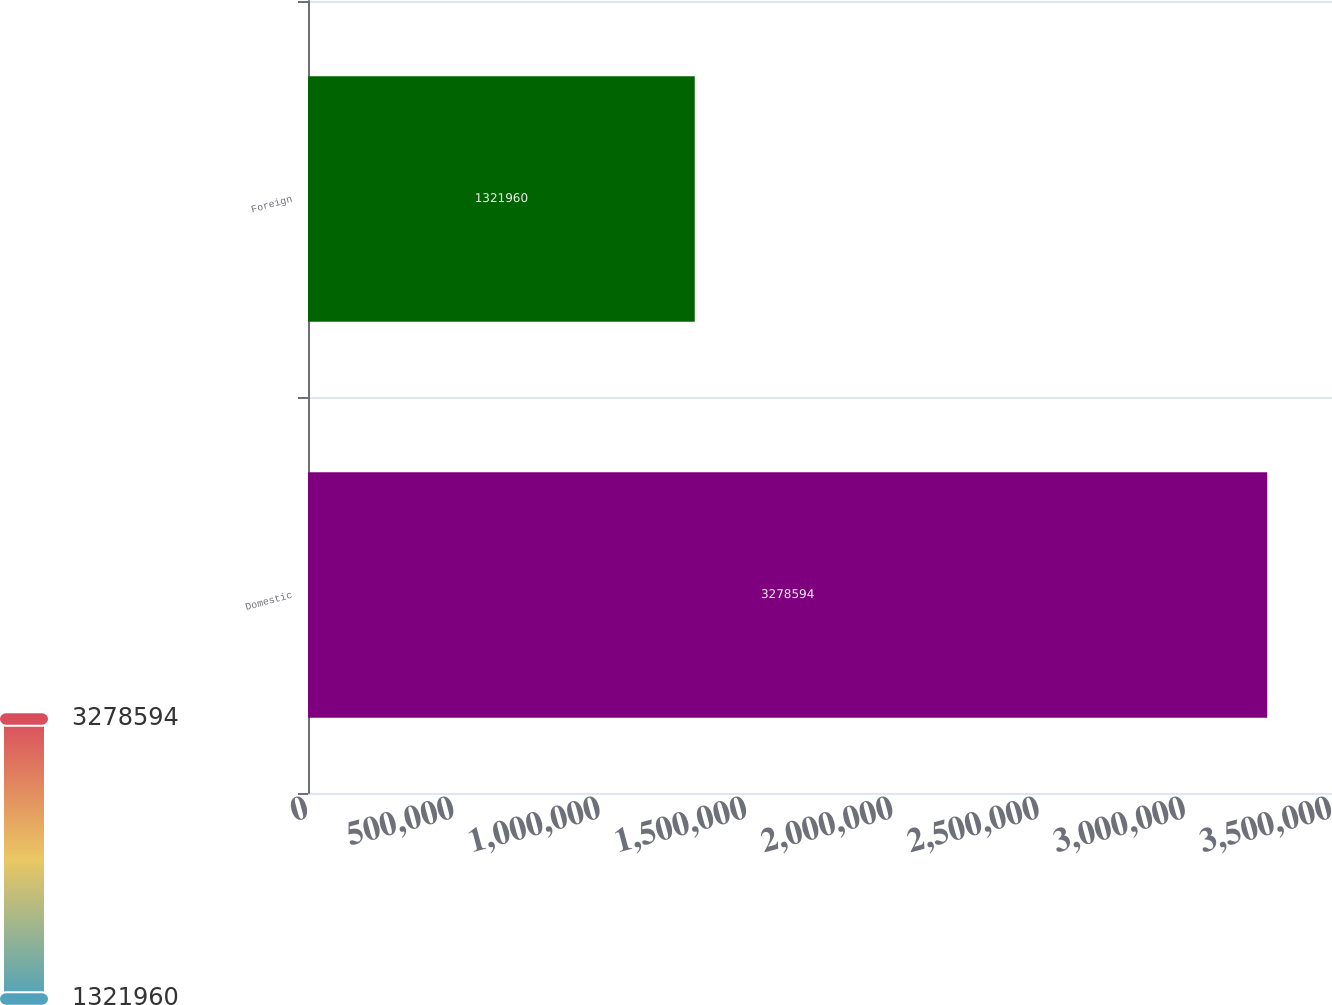Convert chart to OTSL. <chart><loc_0><loc_0><loc_500><loc_500><bar_chart><fcel>Domestic<fcel>Foreign<nl><fcel>3.27859e+06<fcel>1.32196e+06<nl></chart> 